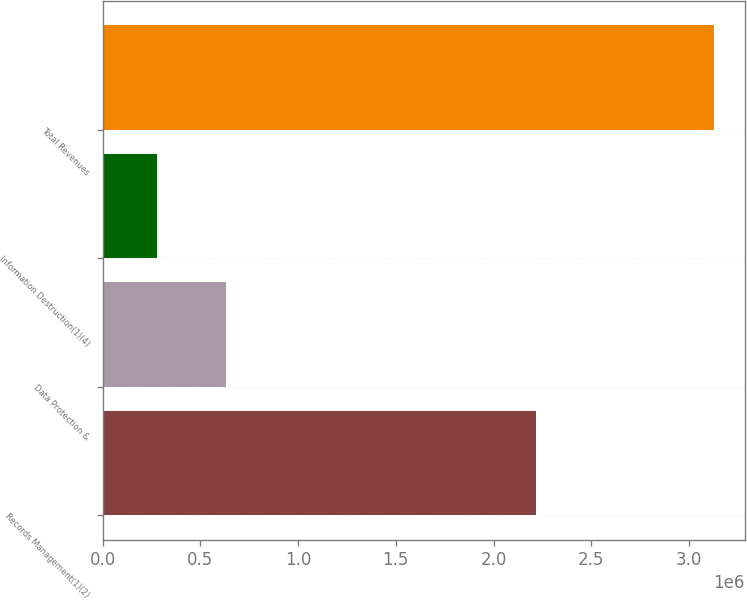<chart> <loc_0><loc_0><loc_500><loc_500><bar_chart><fcel>Records Management(1)(2)<fcel>Data Protection &<fcel>Information Destruction(1)(4)<fcel>Total Revenues<nl><fcel>2.21793e+06<fcel>629101<fcel>280520<fcel>3.12755e+06<nl></chart> 